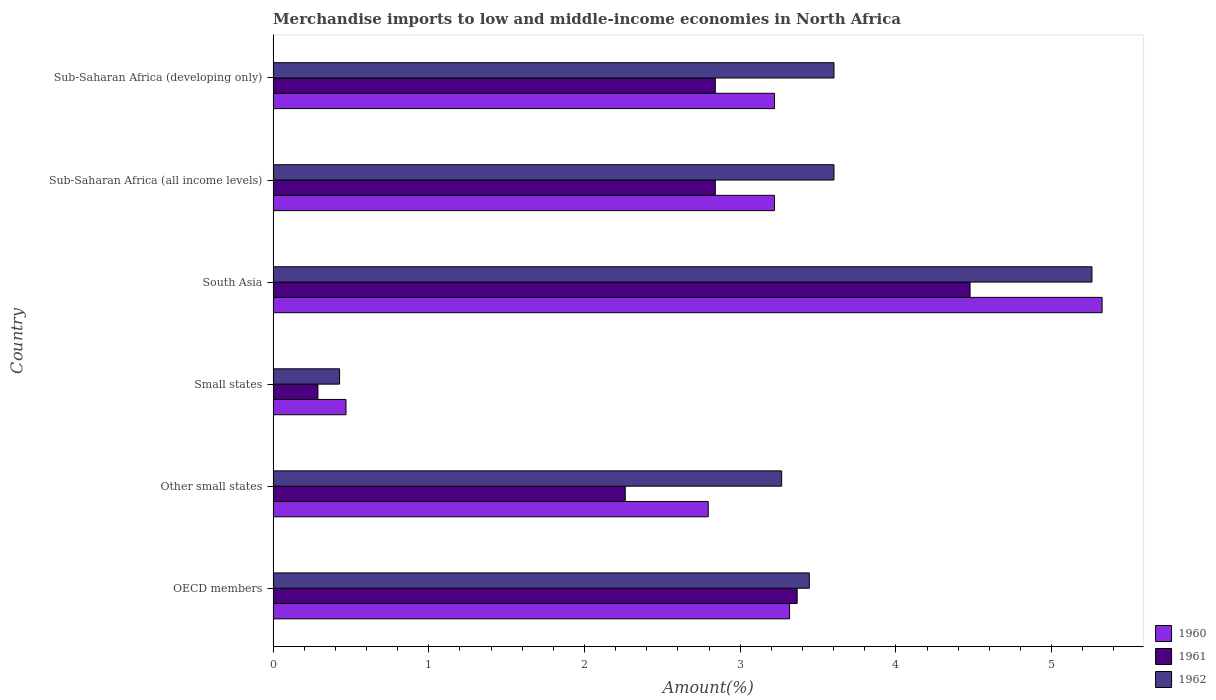How many different coloured bars are there?
Your response must be concise. 3. How many groups of bars are there?
Your answer should be very brief. 6. Are the number of bars on each tick of the Y-axis equal?
Your answer should be compact. Yes. How many bars are there on the 3rd tick from the top?
Offer a terse response. 3. How many bars are there on the 4th tick from the bottom?
Offer a terse response. 3. What is the label of the 5th group of bars from the top?
Give a very brief answer. Other small states. What is the percentage of amount earned from merchandise imports in 1961 in South Asia?
Give a very brief answer. 4.48. Across all countries, what is the maximum percentage of amount earned from merchandise imports in 1960?
Provide a short and direct response. 5.32. Across all countries, what is the minimum percentage of amount earned from merchandise imports in 1960?
Ensure brevity in your answer.  0.47. In which country was the percentage of amount earned from merchandise imports in 1961 maximum?
Make the answer very short. South Asia. In which country was the percentage of amount earned from merchandise imports in 1961 minimum?
Provide a short and direct response. Small states. What is the total percentage of amount earned from merchandise imports in 1960 in the graph?
Your answer should be very brief. 18.34. What is the difference between the percentage of amount earned from merchandise imports in 1960 in Small states and that in Sub-Saharan Africa (all income levels)?
Offer a terse response. -2.75. What is the difference between the percentage of amount earned from merchandise imports in 1961 in Other small states and the percentage of amount earned from merchandise imports in 1960 in South Asia?
Make the answer very short. -3.06. What is the average percentage of amount earned from merchandise imports in 1960 per country?
Your answer should be very brief. 3.06. What is the difference between the percentage of amount earned from merchandise imports in 1961 and percentage of amount earned from merchandise imports in 1960 in Small states?
Ensure brevity in your answer.  -0.18. What is the ratio of the percentage of amount earned from merchandise imports in 1961 in South Asia to that in Sub-Saharan Africa (all income levels)?
Your response must be concise. 1.58. Is the difference between the percentage of amount earned from merchandise imports in 1961 in OECD members and Other small states greater than the difference between the percentage of amount earned from merchandise imports in 1960 in OECD members and Other small states?
Your answer should be very brief. Yes. What is the difference between the highest and the second highest percentage of amount earned from merchandise imports in 1960?
Your answer should be compact. 2.01. What is the difference between the highest and the lowest percentage of amount earned from merchandise imports in 1961?
Give a very brief answer. 4.19. In how many countries, is the percentage of amount earned from merchandise imports in 1961 greater than the average percentage of amount earned from merchandise imports in 1961 taken over all countries?
Offer a terse response. 4. Is the sum of the percentage of amount earned from merchandise imports in 1962 in South Asia and Sub-Saharan Africa (developing only) greater than the maximum percentage of amount earned from merchandise imports in 1960 across all countries?
Your answer should be very brief. Yes. What does the 1st bar from the top in Other small states represents?
Keep it short and to the point. 1962. Is it the case that in every country, the sum of the percentage of amount earned from merchandise imports in 1961 and percentage of amount earned from merchandise imports in 1962 is greater than the percentage of amount earned from merchandise imports in 1960?
Your answer should be compact. Yes. How many bars are there?
Make the answer very short. 18. What is the difference between two consecutive major ticks on the X-axis?
Ensure brevity in your answer.  1. Are the values on the major ticks of X-axis written in scientific E-notation?
Your answer should be very brief. No. Does the graph contain grids?
Give a very brief answer. No. Where does the legend appear in the graph?
Your answer should be compact. Bottom right. How are the legend labels stacked?
Offer a very short reply. Vertical. What is the title of the graph?
Give a very brief answer. Merchandise imports to low and middle-income economies in North Africa. Does "1969" appear as one of the legend labels in the graph?
Your answer should be compact. No. What is the label or title of the X-axis?
Keep it short and to the point. Amount(%). What is the Amount(%) of 1960 in OECD members?
Offer a very short reply. 3.32. What is the Amount(%) in 1961 in OECD members?
Provide a succinct answer. 3.37. What is the Amount(%) in 1962 in OECD members?
Your answer should be very brief. 3.44. What is the Amount(%) of 1960 in Other small states?
Provide a short and direct response. 2.79. What is the Amount(%) in 1961 in Other small states?
Provide a short and direct response. 2.26. What is the Amount(%) of 1962 in Other small states?
Offer a very short reply. 3.27. What is the Amount(%) of 1960 in Small states?
Ensure brevity in your answer.  0.47. What is the Amount(%) in 1961 in Small states?
Give a very brief answer. 0.29. What is the Amount(%) of 1962 in Small states?
Give a very brief answer. 0.43. What is the Amount(%) in 1960 in South Asia?
Your answer should be compact. 5.32. What is the Amount(%) of 1961 in South Asia?
Your answer should be compact. 4.48. What is the Amount(%) in 1962 in South Asia?
Make the answer very short. 5.26. What is the Amount(%) of 1960 in Sub-Saharan Africa (all income levels)?
Your answer should be very brief. 3.22. What is the Amount(%) in 1961 in Sub-Saharan Africa (all income levels)?
Make the answer very short. 2.84. What is the Amount(%) in 1962 in Sub-Saharan Africa (all income levels)?
Provide a succinct answer. 3.6. What is the Amount(%) of 1960 in Sub-Saharan Africa (developing only)?
Your response must be concise. 3.22. What is the Amount(%) in 1961 in Sub-Saharan Africa (developing only)?
Give a very brief answer. 2.84. What is the Amount(%) in 1962 in Sub-Saharan Africa (developing only)?
Keep it short and to the point. 3.6. Across all countries, what is the maximum Amount(%) in 1960?
Your answer should be very brief. 5.32. Across all countries, what is the maximum Amount(%) in 1961?
Offer a very short reply. 4.48. Across all countries, what is the maximum Amount(%) in 1962?
Make the answer very short. 5.26. Across all countries, what is the minimum Amount(%) in 1960?
Provide a succinct answer. 0.47. Across all countries, what is the minimum Amount(%) in 1961?
Provide a short and direct response. 0.29. Across all countries, what is the minimum Amount(%) of 1962?
Your answer should be very brief. 0.43. What is the total Amount(%) in 1960 in the graph?
Offer a very short reply. 18.34. What is the total Amount(%) of 1961 in the graph?
Make the answer very short. 16.07. What is the total Amount(%) of 1962 in the graph?
Offer a terse response. 19.6. What is the difference between the Amount(%) in 1960 in OECD members and that in Other small states?
Your response must be concise. 0.52. What is the difference between the Amount(%) of 1961 in OECD members and that in Other small states?
Provide a succinct answer. 1.1. What is the difference between the Amount(%) in 1962 in OECD members and that in Other small states?
Keep it short and to the point. 0.18. What is the difference between the Amount(%) of 1960 in OECD members and that in Small states?
Give a very brief answer. 2.85. What is the difference between the Amount(%) in 1961 in OECD members and that in Small states?
Ensure brevity in your answer.  3.08. What is the difference between the Amount(%) in 1962 in OECD members and that in Small states?
Offer a terse response. 3.02. What is the difference between the Amount(%) in 1960 in OECD members and that in South Asia?
Your response must be concise. -2.01. What is the difference between the Amount(%) in 1961 in OECD members and that in South Asia?
Your answer should be compact. -1.11. What is the difference between the Amount(%) in 1962 in OECD members and that in South Asia?
Your answer should be very brief. -1.82. What is the difference between the Amount(%) in 1960 in OECD members and that in Sub-Saharan Africa (all income levels)?
Offer a very short reply. 0.1. What is the difference between the Amount(%) of 1961 in OECD members and that in Sub-Saharan Africa (all income levels)?
Your response must be concise. 0.53. What is the difference between the Amount(%) of 1962 in OECD members and that in Sub-Saharan Africa (all income levels)?
Your answer should be very brief. -0.16. What is the difference between the Amount(%) of 1960 in OECD members and that in Sub-Saharan Africa (developing only)?
Your response must be concise. 0.1. What is the difference between the Amount(%) of 1961 in OECD members and that in Sub-Saharan Africa (developing only)?
Your answer should be compact. 0.53. What is the difference between the Amount(%) of 1962 in OECD members and that in Sub-Saharan Africa (developing only)?
Your answer should be compact. -0.16. What is the difference between the Amount(%) of 1960 in Other small states and that in Small states?
Offer a terse response. 2.33. What is the difference between the Amount(%) of 1961 in Other small states and that in Small states?
Your answer should be very brief. 1.97. What is the difference between the Amount(%) of 1962 in Other small states and that in Small states?
Offer a terse response. 2.84. What is the difference between the Amount(%) of 1960 in Other small states and that in South Asia?
Offer a terse response. -2.53. What is the difference between the Amount(%) in 1961 in Other small states and that in South Asia?
Ensure brevity in your answer.  -2.21. What is the difference between the Amount(%) in 1962 in Other small states and that in South Asia?
Provide a short and direct response. -1.99. What is the difference between the Amount(%) of 1960 in Other small states and that in Sub-Saharan Africa (all income levels)?
Offer a very short reply. -0.43. What is the difference between the Amount(%) in 1961 in Other small states and that in Sub-Saharan Africa (all income levels)?
Offer a terse response. -0.58. What is the difference between the Amount(%) of 1962 in Other small states and that in Sub-Saharan Africa (all income levels)?
Provide a succinct answer. -0.34. What is the difference between the Amount(%) of 1960 in Other small states and that in Sub-Saharan Africa (developing only)?
Your response must be concise. -0.43. What is the difference between the Amount(%) of 1961 in Other small states and that in Sub-Saharan Africa (developing only)?
Your response must be concise. -0.58. What is the difference between the Amount(%) in 1962 in Other small states and that in Sub-Saharan Africa (developing only)?
Offer a terse response. -0.34. What is the difference between the Amount(%) of 1960 in Small states and that in South Asia?
Provide a succinct answer. -4.86. What is the difference between the Amount(%) in 1961 in Small states and that in South Asia?
Your response must be concise. -4.19. What is the difference between the Amount(%) in 1962 in Small states and that in South Asia?
Provide a short and direct response. -4.83. What is the difference between the Amount(%) in 1960 in Small states and that in Sub-Saharan Africa (all income levels)?
Your answer should be very brief. -2.75. What is the difference between the Amount(%) of 1961 in Small states and that in Sub-Saharan Africa (all income levels)?
Your answer should be compact. -2.55. What is the difference between the Amount(%) of 1962 in Small states and that in Sub-Saharan Africa (all income levels)?
Your answer should be very brief. -3.18. What is the difference between the Amount(%) in 1960 in Small states and that in Sub-Saharan Africa (developing only)?
Offer a terse response. -2.75. What is the difference between the Amount(%) of 1961 in Small states and that in Sub-Saharan Africa (developing only)?
Provide a short and direct response. -2.55. What is the difference between the Amount(%) in 1962 in Small states and that in Sub-Saharan Africa (developing only)?
Keep it short and to the point. -3.18. What is the difference between the Amount(%) in 1960 in South Asia and that in Sub-Saharan Africa (all income levels)?
Your answer should be compact. 2.1. What is the difference between the Amount(%) in 1961 in South Asia and that in Sub-Saharan Africa (all income levels)?
Offer a very short reply. 1.64. What is the difference between the Amount(%) of 1962 in South Asia and that in Sub-Saharan Africa (all income levels)?
Keep it short and to the point. 1.66. What is the difference between the Amount(%) in 1960 in South Asia and that in Sub-Saharan Africa (developing only)?
Keep it short and to the point. 2.1. What is the difference between the Amount(%) in 1961 in South Asia and that in Sub-Saharan Africa (developing only)?
Offer a terse response. 1.64. What is the difference between the Amount(%) in 1962 in South Asia and that in Sub-Saharan Africa (developing only)?
Give a very brief answer. 1.66. What is the difference between the Amount(%) in 1960 in Sub-Saharan Africa (all income levels) and that in Sub-Saharan Africa (developing only)?
Your answer should be compact. 0. What is the difference between the Amount(%) in 1960 in OECD members and the Amount(%) in 1961 in Other small states?
Your answer should be compact. 1.06. What is the difference between the Amount(%) in 1960 in OECD members and the Amount(%) in 1962 in Other small states?
Your answer should be compact. 0.05. What is the difference between the Amount(%) of 1961 in OECD members and the Amount(%) of 1962 in Other small states?
Ensure brevity in your answer.  0.1. What is the difference between the Amount(%) in 1960 in OECD members and the Amount(%) in 1961 in Small states?
Your answer should be compact. 3.03. What is the difference between the Amount(%) of 1960 in OECD members and the Amount(%) of 1962 in Small states?
Your answer should be compact. 2.89. What is the difference between the Amount(%) of 1961 in OECD members and the Amount(%) of 1962 in Small states?
Your answer should be compact. 2.94. What is the difference between the Amount(%) of 1960 in OECD members and the Amount(%) of 1961 in South Asia?
Your answer should be compact. -1.16. What is the difference between the Amount(%) of 1960 in OECD members and the Amount(%) of 1962 in South Asia?
Provide a short and direct response. -1.94. What is the difference between the Amount(%) in 1961 in OECD members and the Amount(%) in 1962 in South Asia?
Offer a very short reply. -1.89. What is the difference between the Amount(%) in 1960 in OECD members and the Amount(%) in 1961 in Sub-Saharan Africa (all income levels)?
Your answer should be very brief. 0.48. What is the difference between the Amount(%) in 1960 in OECD members and the Amount(%) in 1962 in Sub-Saharan Africa (all income levels)?
Your answer should be very brief. -0.29. What is the difference between the Amount(%) of 1961 in OECD members and the Amount(%) of 1962 in Sub-Saharan Africa (all income levels)?
Ensure brevity in your answer.  -0.24. What is the difference between the Amount(%) in 1960 in OECD members and the Amount(%) in 1961 in Sub-Saharan Africa (developing only)?
Provide a succinct answer. 0.48. What is the difference between the Amount(%) of 1960 in OECD members and the Amount(%) of 1962 in Sub-Saharan Africa (developing only)?
Ensure brevity in your answer.  -0.29. What is the difference between the Amount(%) in 1961 in OECD members and the Amount(%) in 1962 in Sub-Saharan Africa (developing only)?
Make the answer very short. -0.24. What is the difference between the Amount(%) in 1960 in Other small states and the Amount(%) in 1961 in Small states?
Ensure brevity in your answer.  2.51. What is the difference between the Amount(%) in 1960 in Other small states and the Amount(%) in 1962 in Small states?
Offer a terse response. 2.37. What is the difference between the Amount(%) in 1961 in Other small states and the Amount(%) in 1962 in Small states?
Offer a terse response. 1.83. What is the difference between the Amount(%) in 1960 in Other small states and the Amount(%) in 1961 in South Asia?
Make the answer very short. -1.68. What is the difference between the Amount(%) in 1960 in Other small states and the Amount(%) in 1962 in South Asia?
Offer a very short reply. -2.46. What is the difference between the Amount(%) in 1961 in Other small states and the Amount(%) in 1962 in South Asia?
Your answer should be very brief. -3. What is the difference between the Amount(%) of 1960 in Other small states and the Amount(%) of 1961 in Sub-Saharan Africa (all income levels)?
Provide a short and direct response. -0.05. What is the difference between the Amount(%) of 1960 in Other small states and the Amount(%) of 1962 in Sub-Saharan Africa (all income levels)?
Your response must be concise. -0.81. What is the difference between the Amount(%) of 1961 in Other small states and the Amount(%) of 1962 in Sub-Saharan Africa (all income levels)?
Ensure brevity in your answer.  -1.34. What is the difference between the Amount(%) of 1960 in Other small states and the Amount(%) of 1961 in Sub-Saharan Africa (developing only)?
Your answer should be compact. -0.05. What is the difference between the Amount(%) in 1960 in Other small states and the Amount(%) in 1962 in Sub-Saharan Africa (developing only)?
Make the answer very short. -0.81. What is the difference between the Amount(%) of 1961 in Other small states and the Amount(%) of 1962 in Sub-Saharan Africa (developing only)?
Ensure brevity in your answer.  -1.34. What is the difference between the Amount(%) of 1960 in Small states and the Amount(%) of 1961 in South Asia?
Keep it short and to the point. -4.01. What is the difference between the Amount(%) in 1960 in Small states and the Amount(%) in 1962 in South Asia?
Provide a short and direct response. -4.79. What is the difference between the Amount(%) of 1961 in Small states and the Amount(%) of 1962 in South Asia?
Offer a very short reply. -4.97. What is the difference between the Amount(%) of 1960 in Small states and the Amount(%) of 1961 in Sub-Saharan Africa (all income levels)?
Provide a short and direct response. -2.37. What is the difference between the Amount(%) of 1960 in Small states and the Amount(%) of 1962 in Sub-Saharan Africa (all income levels)?
Keep it short and to the point. -3.13. What is the difference between the Amount(%) of 1961 in Small states and the Amount(%) of 1962 in Sub-Saharan Africa (all income levels)?
Provide a succinct answer. -3.31. What is the difference between the Amount(%) of 1960 in Small states and the Amount(%) of 1961 in Sub-Saharan Africa (developing only)?
Offer a very short reply. -2.37. What is the difference between the Amount(%) in 1960 in Small states and the Amount(%) in 1962 in Sub-Saharan Africa (developing only)?
Provide a short and direct response. -3.13. What is the difference between the Amount(%) of 1961 in Small states and the Amount(%) of 1962 in Sub-Saharan Africa (developing only)?
Make the answer very short. -3.31. What is the difference between the Amount(%) of 1960 in South Asia and the Amount(%) of 1961 in Sub-Saharan Africa (all income levels)?
Your response must be concise. 2.48. What is the difference between the Amount(%) in 1960 in South Asia and the Amount(%) in 1962 in Sub-Saharan Africa (all income levels)?
Keep it short and to the point. 1.72. What is the difference between the Amount(%) in 1961 in South Asia and the Amount(%) in 1962 in Sub-Saharan Africa (all income levels)?
Offer a terse response. 0.87. What is the difference between the Amount(%) of 1960 in South Asia and the Amount(%) of 1961 in Sub-Saharan Africa (developing only)?
Provide a succinct answer. 2.48. What is the difference between the Amount(%) in 1960 in South Asia and the Amount(%) in 1962 in Sub-Saharan Africa (developing only)?
Offer a terse response. 1.72. What is the difference between the Amount(%) in 1961 in South Asia and the Amount(%) in 1962 in Sub-Saharan Africa (developing only)?
Ensure brevity in your answer.  0.87. What is the difference between the Amount(%) in 1960 in Sub-Saharan Africa (all income levels) and the Amount(%) in 1961 in Sub-Saharan Africa (developing only)?
Make the answer very short. 0.38. What is the difference between the Amount(%) of 1960 in Sub-Saharan Africa (all income levels) and the Amount(%) of 1962 in Sub-Saharan Africa (developing only)?
Keep it short and to the point. -0.38. What is the difference between the Amount(%) of 1961 in Sub-Saharan Africa (all income levels) and the Amount(%) of 1962 in Sub-Saharan Africa (developing only)?
Offer a terse response. -0.76. What is the average Amount(%) of 1960 per country?
Provide a short and direct response. 3.06. What is the average Amount(%) of 1961 per country?
Make the answer very short. 2.68. What is the average Amount(%) in 1962 per country?
Your answer should be very brief. 3.27. What is the difference between the Amount(%) of 1960 and Amount(%) of 1961 in OECD members?
Provide a short and direct response. -0.05. What is the difference between the Amount(%) of 1960 and Amount(%) of 1962 in OECD members?
Keep it short and to the point. -0.13. What is the difference between the Amount(%) of 1961 and Amount(%) of 1962 in OECD members?
Give a very brief answer. -0.08. What is the difference between the Amount(%) in 1960 and Amount(%) in 1961 in Other small states?
Your answer should be very brief. 0.53. What is the difference between the Amount(%) in 1960 and Amount(%) in 1962 in Other small states?
Your answer should be compact. -0.47. What is the difference between the Amount(%) of 1961 and Amount(%) of 1962 in Other small states?
Provide a succinct answer. -1. What is the difference between the Amount(%) in 1960 and Amount(%) in 1961 in Small states?
Offer a terse response. 0.18. What is the difference between the Amount(%) of 1960 and Amount(%) of 1962 in Small states?
Provide a succinct answer. 0.04. What is the difference between the Amount(%) in 1961 and Amount(%) in 1962 in Small states?
Offer a very short reply. -0.14. What is the difference between the Amount(%) of 1960 and Amount(%) of 1961 in South Asia?
Your answer should be very brief. 0.85. What is the difference between the Amount(%) of 1960 and Amount(%) of 1962 in South Asia?
Your answer should be very brief. 0.07. What is the difference between the Amount(%) of 1961 and Amount(%) of 1962 in South Asia?
Keep it short and to the point. -0.78. What is the difference between the Amount(%) in 1960 and Amount(%) in 1961 in Sub-Saharan Africa (all income levels)?
Ensure brevity in your answer.  0.38. What is the difference between the Amount(%) in 1960 and Amount(%) in 1962 in Sub-Saharan Africa (all income levels)?
Your answer should be very brief. -0.38. What is the difference between the Amount(%) in 1961 and Amount(%) in 1962 in Sub-Saharan Africa (all income levels)?
Make the answer very short. -0.76. What is the difference between the Amount(%) in 1960 and Amount(%) in 1961 in Sub-Saharan Africa (developing only)?
Offer a very short reply. 0.38. What is the difference between the Amount(%) in 1960 and Amount(%) in 1962 in Sub-Saharan Africa (developing only)?
Provide a succinct answer. -0.38. What is the difference between the Amount(%) in 1961 and Amount(%) in 1962 in Sub-Saharan Africa (developing only)?
Offer a terse response. -0.76. What is the ratio of the Amount(%) in 1960 in OECD members to that in Other small states?
Give a very brief answer. 1.19. What is the ratio of the Amount(%) of 1961 in OECD members to that in Other small states?
Keep it short and to the point. 1.49. What is the ratio of the Amount(%) in 1962 in OECD members to that in Other small states?
Keep it short and to the point. 1.05. What is the ratio of the Amount(%) of 1960 in OECD members to that in Small states?
Provide a succinct answer. 7.09. What is the ratio of the Amount(%) of 1961 in OECD members to that in Small states?
Your answer should be very brief. 11.69. What is the ratio of the Amount(%) in 1962 in OECD members to that in Small states?
Offer a terse response. 8.07. What is the ratio of the Amount(%) of 1960 in OECD members to that in South Asia?
Ensure brevity in your answer.  0.62. What is the ratio of the Amount(%) in 1961 in OECD members to that in South Asia?
Ensure brevity in your answer.  0.75. What is the ratio of the Amount(%) in 1962 in OECD members to that in South Asia?
Offer a terse response. 0.65. What is the ratio of the Amount(%) of 1960 in OECD members to that in Sub-Saharan Africa (all income levels)?
Your response must be concise. 1.03. What is the ratio of the Amount(%) of 1961 in OECD members to that in Sub-Saharan Africa (all income levels)?
Give a very brief answer. 1.19. What is the ratio of the Amount(%) in 1962 in OECD members to that in Sub-Saharan Africa (all income levels)?
Provide a succinct answer. 0.96. What is the ratio of the Amount(%) of 1960 in OECD members to that in Sub-Saharan Africa (developing only)?
Keep it short and to the point. 1.03. What is the ratio of the Amount(%) of 1961 in OECD members to that in Sub-Saharan Africa (developing only)?
Your answer should be compact. 1.19. What is the ratio of the Amount(%) in 1962 in OECD members to that in Sub-Saharan Africa (developing only)?
Provide a succinct answer. 0.96. What is the ratio of the Amount(%) of 1960 in Other small states to that in Small states?
Your answer should be compact. 5.97. What is the ratio of the Amount(%) of 1961 in Other small states to that in Small states?
Provide a short and direct response. 7.86. What is the ratio of the Amount(%) in 1962 in Other small states to that in Small states?
Provide a succinct answer. 7.65. What is the ratio of the Amount(%) in 1960 in Other small states to that in South Asia?
Your answer should be very brief. 0.52. What is the ratio of the Amount(%) in 1961 in Other small states to that in South Asia?
Provide a short and direct response. 0.51. What is the ratio of the Amount(%) of 1962 in Other small states to that in South Asia?
Provide a short and direct response. 0.62. What is the ratio of the Amount(%) of 1960 in Other small states to that in Sub-Saharan Africa (all income levels)?
Give a very brief answer. 0.87. What is the ratio of the Amount(%) of 1961 in Other small states to that in Sub-Saharan Africa (all income levels)?
Your answer should be compact. 0.8. What is the ratio of the Amount(%) in 1962 in Other small states to that in Sub-Saharan Africa (all income levels)?
Keep it short and to the point. 0.91. What is the ratio of the Amount(%) in 1960 in Other small states to that in Sub-Saharan Africa (developing only)?
Ensure brevity in your answer.  0.87. What is the ratio of the Amount(%) of 1961 in Other small states to that in Sub-Saharan Africa (developing only)?
Offer a very short reply. 0.8. What is the ratio of the Amount(%) in 1962 in Other small states to that in Sub-Saharan Africa (developing only)?
Keep it short and to the point. 0.91. What is the ratio of the Amount(%) in 1960 in Small states to that in South Asia?
Ensure brevity in your answer.  0.09. What is the ratio of the Amount(%) in 1961 in Small states to that in South Asia?
Keep it short and to the point. 0.06. What is the ratio of the Amount(%) of 1962 in Small states to that in South Asia?
Offer a terse response. 0.08. What is the ratio of the Amount(%) of 1960 in Small states to that in Sub-Saharan Africa (all income levels)?
Give a very brief answer. 0.15. What is the ratio of the Amount(%) of 1961 in Small states to that in Sub-Saharan Africa (all income levels)?
Provide a succinct answer. 0.1. What is the ratio of the Amount(%) of 1962 in Small states to that in Sub-Saharan Africa (all income levels)?
Keep it short and to the point. 0.12. What is the ratio of the Amount(%) of 1960 in Small states to that in Sub-Saharan Africa (developing only)?
Give a very brief answer. 0.15. What is the ratio of the Amount(%) in 1961 in Small states to that in Sub-Saharan Africa (developing only)?
Ensure brevity in your answer.  0.1. What is the ratio of the Amount(%) of 1962 in Small states to that in Sub-Saharan Africa (developing only)?
Offer a terse response. 0.12. What is the ratio of the Amount(%) in 1960 in South Asia to that in Sub-Saharan Africa (all income levels)?
Provide a short and direct response. 1.65. What is the ratio of the Amount(%) in 1961 in South Asia to that in Sub-Saharan Africa (all income levels)?
Provide a succinct answer. 1.58. What is the ratio of the Amount(%) of 1962 in South Asia to that in Sub-Saharan Africa (all income levels)?
Provide a short and direct response. 1.46. What is the ratio of the Amount(%) of 1960 in South Asia to that in Sub-Saharan Africa (developing only)?
Provide a succinct answer. 1.65. What is the ratio of the Amount(%) of 1961 in South Asia to that in Sub-Saharan Africa (developing only)?
Your response must be concise. 1.58. What is the ratio of the Amount(%) of 1962 in South Asia to that in Sub-Saharan Africa (developing only)?
Make the answer very short. 1.46. What is the ratio of the Amount(%) in 1962 in Sub-Saharan Africa (all income levels) to that in Sub-Saharan Africa (developing only)?
Offer a very short reply. 1. What is the difference between the highest and the second highest Amount(%) in 1960?
Your answer should be compact. 2.01. What is the difference between the highest and the second highest Amount(%) in 1961?
Give a very brief answer. 1.11. What is the difference between the highest and the second highest Amount(%) of 1962?
Make the answer very short. 1.66. What is the difference between the highest and the lowest Amount(%) in 1960?
Provide a short and direct response. 4.86. What is the difference between the highest and the lowest Amount(%) of 1961?
Offer a very short reply. 4.19. What is the difference between the highest and the lowest Amount(%) in 1962?
Ensure brevity in your answer.  4.83. 